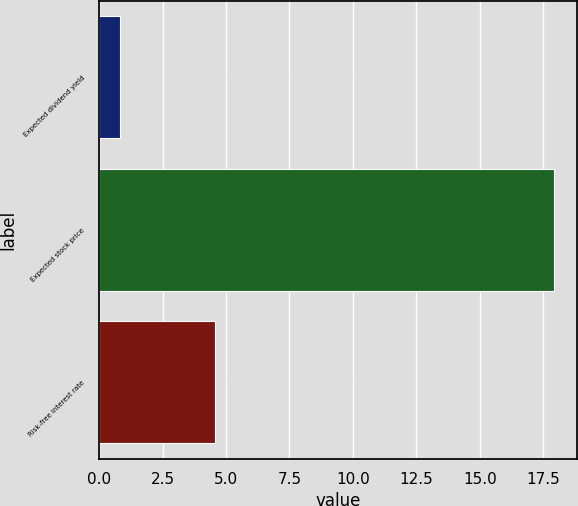Convert chart to OTSL. <chart><loc_0><loc_0><loc_500><loc_500><bar_chart><fcel>Expected dividend yield<fcel>Expected stock price<fcel>Risk-free interest rate<nl><fcel>0.81<fcel>17.94<fcel>4.55<nl></chart> 